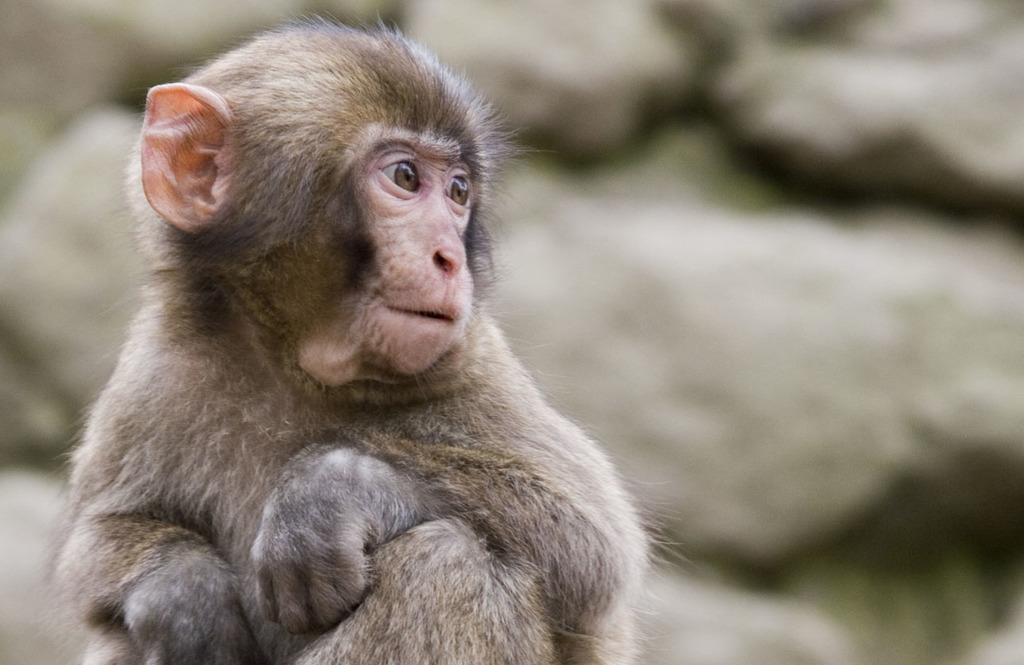What animal is present in the image? There is a monkey in the image. Can you describe the background of the image? The background of the image is blurred. What type of stamp is the monkey holding in the image? There is no stamp present in the image; it only features a monkey. 